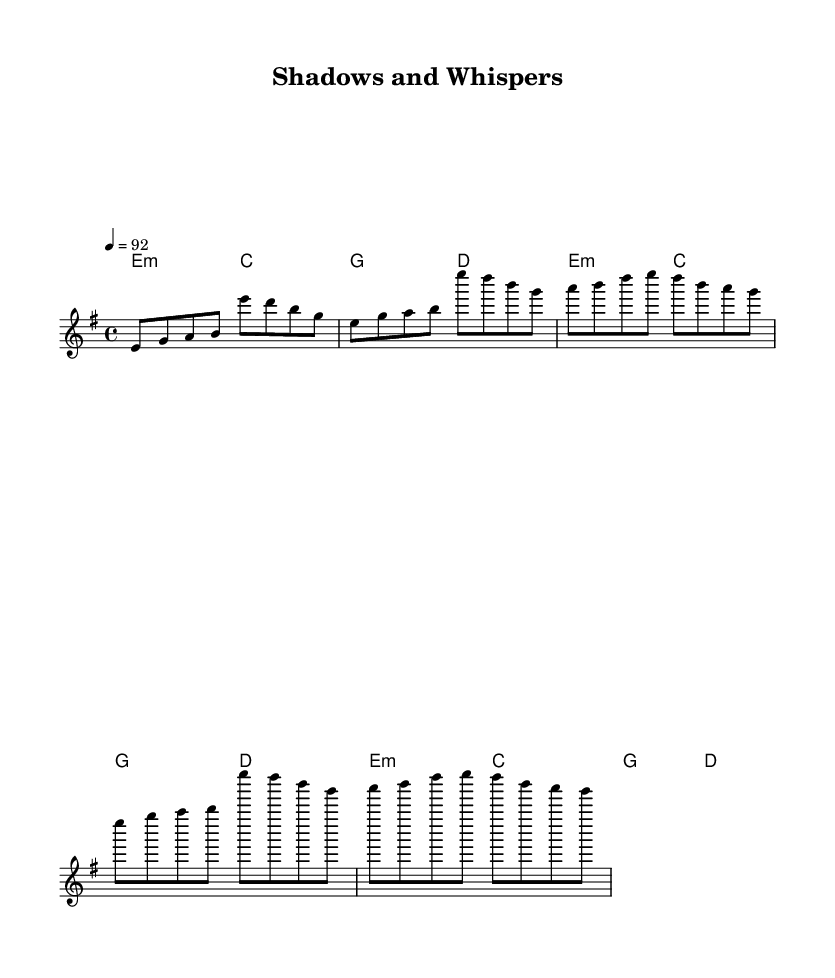What is the key signature of this music? The key signature indicated in the music is E minor, which typically has one sharp (F#). This is shown at the beginning of the staff.
Answer: E minor What is the time signature of this music? The time signature is 4/4, which means there are four beats in each measure, and the quarter note receives one beat. This is indicated at the beginning of the score.
Answer: 4/4 What is the tempo marking for this piece? The tempo marking is 92, which specifies that the beat should be played at a speed of 92 beats per minute. This is noted at the start of the score.
Answer: 92 How many measures are in the verse section? The verse consists of 2 measures as indicated by the grouping of music notation under the verse lyrics. Each line of the verse contains a separate measure.
Answer: 2 What type of musical work is this? This piece is described as a rap, as indicated by the thematic content of the lyrics, which focus on covert missions and intelligence gathering, typical of rap narratives.
Answer: Rap What is the lyrical theme of the refrain? The refrain focuses on themes of urgency and precision, specifically mentioning "Close calls and whispers" which highlights the tension present during covert operations.
Answer: Urgency 